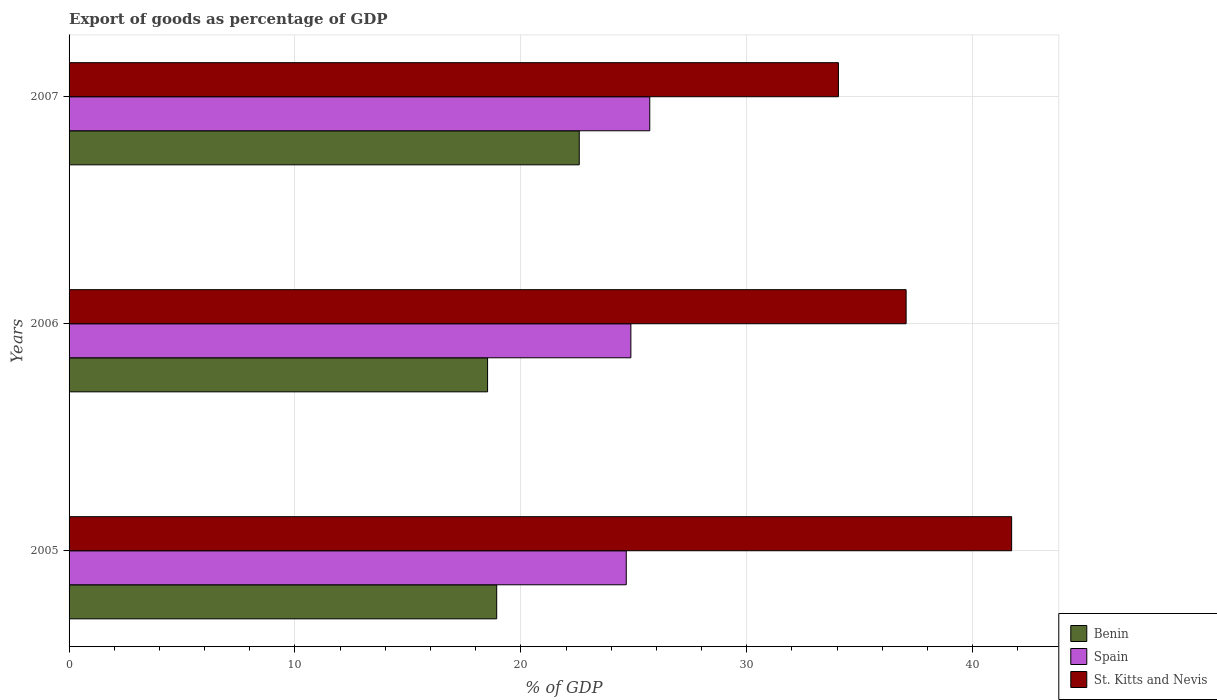Are the number of bars on each tick of the Y-axis equal?
Give a very brief answer. Yes. How many bars are there on the 2nd tick from the top?
Offer a very short reply. 3. How many bars are there on the 2nd tick from the bottom?
Offer a very short reply. 3. What is the label of the 2nd group of bars from the top?
Give a very brief answer. 2006. In how many cases, is the number of bars for a given year not equal to the number of legend labels?
Ensure brevity in your answer.  0. What is the export of goods as percentage of GDP in Benin in 2005?
Make the answer very short. 18.93. Across all years, what is the maximum export of goods as percentage of GDP in St. Kitts and Nevis?
Give a very brief answer. 41.73. Across all years, what is the minimum export of goods as percentage of GDP in Benin?
Your answer should be compact. 18.53. In which year was the export of goods as percentage of GDP in Benin maximum?
Your answer should be compact. 2007. What is the total export of goods as percentage of GDP in St. Kitts and Nevis in the graph?
Your answer should be compact. 112.85. What is the difference between the export of goods as percentage of GDP in Spain in 2005 and that in 2006?
Your answer should be very brief. -0.2. What is the difference between the export of goods as percentage of GDP in St. Kitts and Nevis in 2006 and the export of goods as percentage of GDP in Spain in 2005?
Ensure brevity in your answer.  12.39. What is the average export of goods as percentage of GDP in St. Kitts and Nevis per year?
Provide a succinct answer. 37.62. In the year 2007, what is the difference between the export of goods as percentage of GDP in St. Kitts and Nevis and export of goods as percentage of GDP in Benin?
Give a very brief answer. 11.47. What is the ratio of the export of goods as percentage of GDP in Spain in 2006 to that in 2007?
Offer a very short reply. 0.97. Is the export of goods as percentage of GDP in Benin in 2005 less than that in 2007?
Make the answer very short. Yes. What is the difference between the highest and the second highest export of goods as percentage of GDP in Benin?
Ensure brevity in your answer.  3.65. What is the difference between the highest and the lowest export of goods as percentage of GDP in Spain?
Make the answer very short. 1.04. What does the 1st bar from the top in 2006 represents?
Provide a short and direct response. St. Kitts and Nevis. Is it the case that in every year, the sum of the export of goods as percentage of GDP in Benin and export of goods as percentage of GDP in St. Kitts and Nevis is greater than the export of goods as percentage of GDP in Spain?
Your response must be concise. Yes. How many bars are there?
Keep it short and to the point. 9. Does the graph contain any zero values?
Provide a short and direct response. No. Does the graph contain grids?
Your answer should be very brief. Yes. How many legend labels are there?
Offer a very short reply. 3. How are the legend labels stacked?
Provide a succinct answer. Vertical. What is the title of the graph?
Give a very brief answer. Export of goods as percentage of GDP. Does "Djibouti" appear as one of the legend labels in the graph?
Offer a terse response. No. What is the label or title of the X-axis?
Your response must be concise. % of GDP. What is the % of GDP of Benin in 2005?
Offer a terse response. 18.93. What is the % of GDP of Spain in 2005?
Ensure brevity in your answer.  24.67. What is the % of GDP in St. Kitts and Nevis in 2005?
Make the answer very short. 41.73. What is the % of GDP of Benin in 2006?
Keep it short and to the point. 18.53. What is the % of GDP in Spain in 2006?
Provide a succinct answer. 24.87. What is the % of GDP in St. Kitts and Nevis in 2006?
Ensure brevity in your answer.  37.06. What is the % of GDP of Benin in 2007?
Make the answer very short. 22.59. What is the % of GDP in Spain in 2007?
Make the answer very short. 25.71. What is the % of GDP of St. Kitts and Nevis in 2007?
Provide a succinct answer. 34.06. Across all years, what is the maximum % of GDP in Benin?
Offer a terse response. 22.59. Across all years, what is the maximum % of GDP of Spain?
Make the answer very short. 25.71. Across all years, what is the maximum % of GDP in St. Kitts and Nevis?
Provide a succinct answer. 41.73. Across all years, what is the minimum % of GDP in Benin?
Give a very brief answer. 18.53. Across all years, what is the minimum % of GDP of Spain?
Provide a short and direct response. 24.67. Across all years, what is the minimum % of GDP in St. Kitts and Nevis?
Provide a short and direct response. 34.06. What is the total % of GDP in Benin in the graph?
Your answer should be very brief. 60.05. What is the total % of GDP in Spain in the graph?
Your response must be concise. 75.25. What is the total % of GDP of St. Kitts and Nevis in the graph?
Keep it short and to the point. 112.85. What is the difference between the % of GDP in Benin in 2005 and that in 2006?
Your answer should be compact. 0.4. What is the difference between the % of GDP in Spain in 2005 and that in 2006?
Your answer should be very brief. -0.2. What is the difference between the % of GDP of St. Kitts and Nevis in 2005 and that in 2006?
Provide a succinct answer. 4.67. What is the difference between the % of GDP of Benin in 2005 and that in 2007?
Your answer should be very brief. -3.65. What is the difference between the % of GDP of Spain in 2005 and that in 2007?
Your answer should be very brief. -1.04. What is the difference between the % of GDP in St. Kitts and Nevis in 2005 and that in 2007?
Your answer should be compact. 7.67. What is the difference between the % of GDP in Benin in 2006 and that in 2007?
Offer a terse response. -4.06. What is the difference between the % of GDP in Spain in 2006 and that in 2007?
Offer a very short reply. -0.84. What is the difference between the % of GDP of St. Kitts and Nevis in 2006 and that in 2007?
Ensure brevity in your answer.  3. What is the difference between the % of GDP of Benin in 2005 and the % of GDP of Spain in 2006?
Offer a terse response. -5.94. What is the difference between the % of GDP in Benin in 2005 and the % of GDP in St. Kitts and Nevis in 2006?
Your response must be concise. -18.12. What is the difference between the % of GDP in Spain in 2005 and the % of GDP in St. Kitts and Nevis in 2006?
Ensure brevity in your answer.  -12.39. What is the difference between the % of GDP in Benin in 2005 and the % of GDP in Spain in 2007?
Provide a succinct answer. -6.78. What is the difference between the % of GDP in Benin in 2005 and the % of GDP in St. Kitts and Nevis in 2007?
Your answer should be very brief. -15.13. What is the difference between the % of GDP in Spain in 2005 and the % of GDP in St. Kitts and Nevis in 2007?
Your response must be concise. -9.39. What is the difference between the % of GDP in Benin in 2006 and the % of GDP in Spain in 2007?
Keep it short and to the point. -7.18. What is the difference between the % of GDP of Benin in 2006 and the % of GDP of St. Kitts and Nevis in 2007?
Provide a short and direct response. -15.53. What is the difference between the % of GDP in Spain in 2006 and the % of GDP in St. Kitts and Nevis in 2007?
Give a very brief answer. -9.19. What is the average % of GDP in Benin per year?
Make the answer very short. 20.02. What is the average % of GDP of Spain per year?
Make the answer very short. 25.08. What is the average % of GDP of St. Kitts and Nevis per year?
Offer a terse response. 37.62. In the year 2005, what is the difference between the % of GDP in Benin and % of GDP in Spain?
Your response must be concise. -5.74. In the year 2005, what is the difference between the % of GDP of Benin and % of GDP of St. Kitts and Nevis?
Make the answer very short. -22.8. In the year 2005, what is the difference between the % of GDP of Spain and % of GDP of St. Kitts and Nevis?
Provide a short and direct response. -17.06. In the year 2006, what is the difference between the % of GDP of Benin and % of GDP of Spain?
Make the answer very short. -6.34. In the year 2006, what is the difference between the % of GDP of Benin and % of GDP of St. Kitts and Nevis?
Offer a very short reply. -18.53. In the year 2006, what is the difference between the % of GDP of Spain and % of GDP of St. Kitts and Nevis?
Your answer should be compact. -12.19. In the year 2007, what is the difference between the % of GDP in Benin and % of GDP in Spain?
Your response must be concise. -3.12. In the year 2007, what is the difference between the % of GDP of Benin and % of GDP of St. Kitts and Nevis?
Offer a terse response. -11.47. In the year 2007, what is the difference between the % of GDP in Spain and % of GDP in St. Kitts and Nevis?
Offer a very short reply. -8.35. What is the ratio of the % of GDP in Benin in 2005 to that in 2006?
Make the answer very short. 1.02. What is the ratio of the % of GDP in St. Kitts and Nevis in 2005 to that in 2006?
Your answer should be very brief. 1.13. What is the ratio of the % of GDP in Benin in 2005 to that in 2007?
Give a very brief answer. 0.84. What is the ratio of the % of GDP of Spain in 2005 to that in 2007?
Your response must be concise. 0.96. What is the ratio of the % of GDP of St. Kitts and Nevis in 2005 to that in 2007?
Keep it short and to the point. 1.23. What is the ratio of the % of GDP in Benin in 2006 to that in 2007?
Offer a terse response. 0.82. What is the ratio of the % of GDP in Spain in 2006 to that in 2007?
Give a very brief answer. 0.97. What is the ratio of the % of GDP in St. Kitts and Nevis in 2006 to that in 2007?
Your answer should be compact. 1.09. What is the difference between the highest and the second highest % of GDP of Benin?
Your answer should be compact. 3.65. What is the difference between the highest and the second highest % of GDP in Spain?
Provide a short and direct response. 0.84. What is the difference between the highest and the second highest % of GDP of St. Kitts and Nevis?
Provide a succinct answer. 4.67. What is the difference between the highest and the lowest % of GDP of Benin?
Ensure brevity in your answer.  4.06. What is the difference between the highest and the lowest % of GDP in Spain?
Provide a short and direct response. 1.04. What is the difference between the highest and the lowest % of GDP in St. Kitts and Nevis?
Offer a terse response. 7.67. 